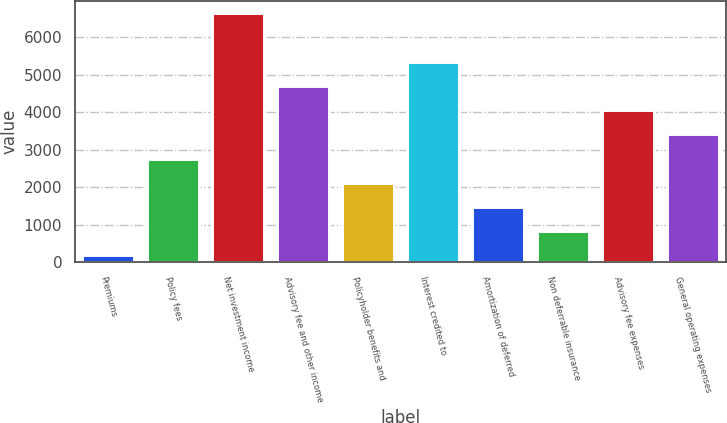Convert chart to OTSL. <chart><loc_0><loc_0><loc_500><loc_500><bar_chart><fcel>Premiums<fcel>Policy fees<fcel>Net investment income<fcel>Advisory fee and other income<fcel>Policyholder benefits and<fcel>Interest credited to<fcel>Amortization of deferred<fcel>Non deferrable insurance<fcel>Advisory fee expenses<fcel>General operating expenses<nl><fcel>188<fcel>2764<fcel>6628<fcel>4696<fcel>2120<fcel>5340<fcel>1476<fcel>832<fcel>4052<fcel>3408<nl></chart> 